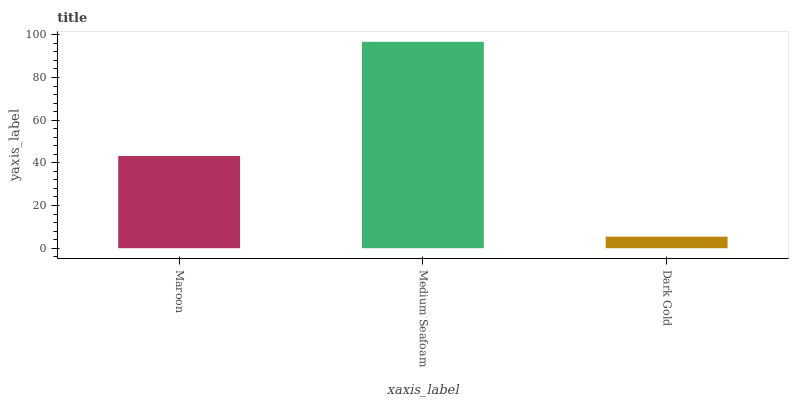Is Dark Gold the minimum?
Answer yes or no. Yes. Is Medium Seafoam the maximum?
Answer yes or no. Yes. Is Medium Seafoam the minimum?
Answer yes or no. No. Is Dark Gold the maximum?
Answer yes or no. No. Is Medium Seafoam greater than Dark Gold?
Answer yes or no. Yes. Is Dark Gold less than Medium Seafoam?
Answer yes or no. Yes. Is Dark Gold greater than Medium Seafoam?
Answer yes or no. No. Is Medium Seafoam less than Dark Gold?
Answer yes or no. No. Is Maroon the high median?
Answer yes or no. Yes. Is Maroon the low median?
Answer yes or no. Yes. Is Dark Gold the high median?
Answer yes or no. No. Is Medium Seafoam the low median?
Answer yes or no. No. 